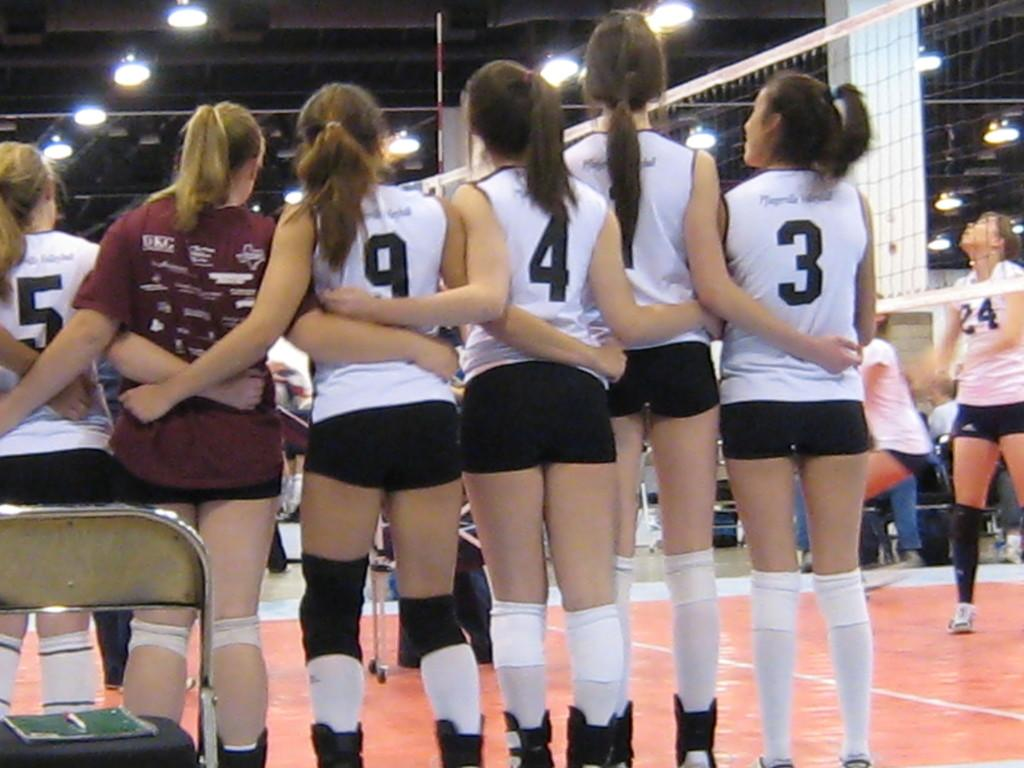Provide a one-sentence caption for the provided image. Female athletes wear shirts with 5, 9, 4 and 3 on the backs. 